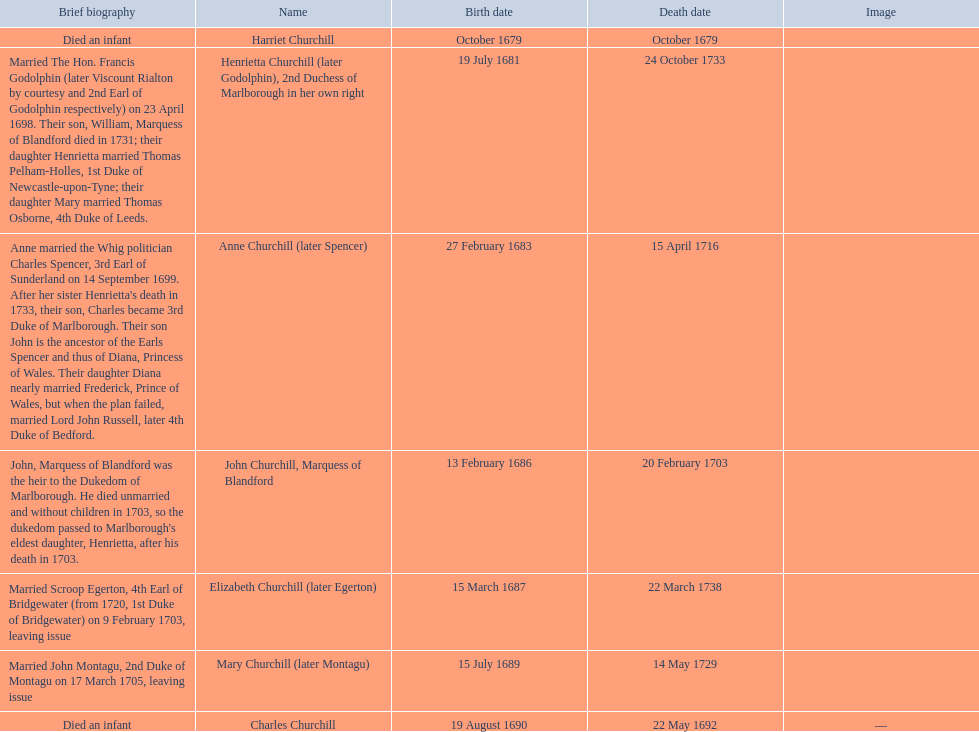How many children were born in february? 2. 